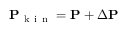<formula> <loc_0><loc_0><loc_500><loc_500>P _ { k i n } = P + \Delta P</formula> 